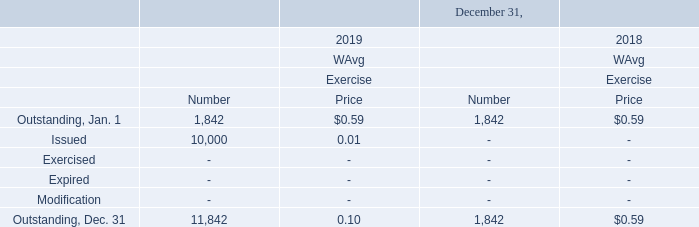NOTE 10 – COMMON STOCK PURCHASE WARRANTS
Our warrant activity during the years ended December 31, 2019 and 2018 is shown below (in thousands except price data):
In connection with the issuance of the $10.0 million secured promissory notes in December 2013, we issued common stock purchase warrants (“warrants”) exercisable for 60 thousand shares of our common stock having an exercise price of $2.52 per share (after giving effect to our one-for-five reverse stock split) with an expiration date in December 2020. These warrants contain a cashless exercise feature (See Note 7).
As part of our July 2017 private placement transaction with Mr. Schutte, we issued warrants to purchase 1,782,531 shares of our common stock. The warrants are immediately exercisable at a price of $0.528 per share and expire five years after issuance (See Note 8). We have assigned a relative fair value of $495 thousand to the warrants out of the total $4.0 million proceeds from the private placement transaction and have accounted for these warrants as equity.
On June 28, 2019 as part of the changes made to the loan agreements we had with Mr. Schutte, each having an original due date of January 2, 2020, we issued to him a warrant to purchase 10.0 million shares of our common stock exercisable at a price of $0.01 per share and expire five years after issuance. We obtained a valuation of fair value on the warrant and $1.145 million was allocated to the warrant and accounted for as equity. (see Note 7 and Note 8). The warrant was assigned and transferred by Mr. Schutte to AD Pharma on June 28, 2019.
How many common shares were purchased in July 2017? As part of our july 2017 private placement transaction with mr. schutte, we issued warrants to purchase 1,782,531 shares of our common stock. What was the exercise price of that 10 million common stock for Mr. Schutte in 2019 On june 28, 2019 as part of the changes made to the loan agreements we had with mr. schutte, each having an original due date of january 2, 2020, we issued to him a warrant to purchase 10.0 million shares of our common stock exercisable at a price of $0.01 per share and expire five years after issuance. What was the expiration date of the 10 million secured promissory notes issued in December 2013?  In connection with the issuance of the $10.0 million secured promissory notes in december 2013, we issued common stock purchase warrants (“warrants”) exercisable for 60 thousand shares of our common stock having an exercise price of $2.52 per share (after giving effect to our one-for-five reverse stock split) with an expiration date in december 2020. What is the difference between the ending outstanding common stock purchase warrants in 2018 and 2019?  0.59 - 0.1 
Answer: 0.49. What is the percentage increase in ending outstanding common stock purchase warrants from 2018 to 2019?
Answer scale should be: percent. 10,000 / 1,842 
Answer: 542.89. How much was the percentage decrease in ending price of outstanding common stock purchase warrants from 2018 to 2019?
Answer scale should be: percent. (0.59 - 0.10) / 0.59 
Answer: 83.05. 